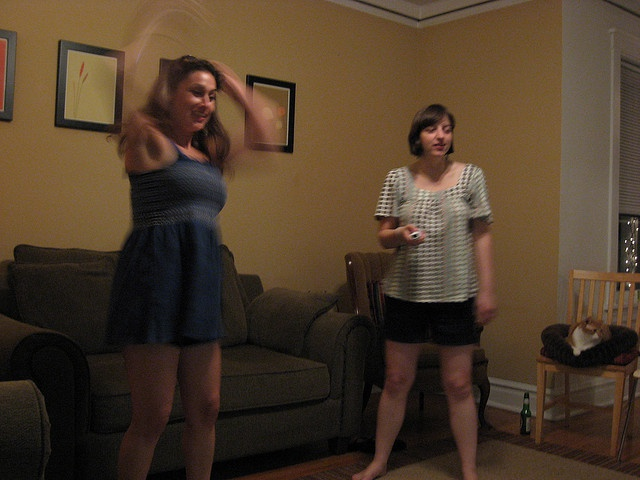Describe the objects in this image and their specific colors. I can see couch in brown, black, and maroon tones, people in gray, black, maroon, and brown tones, people in gray, black, and maroon tones, chair in gray, black, and maroon tones, and chair in gray, black, and maroon tones in this image. 